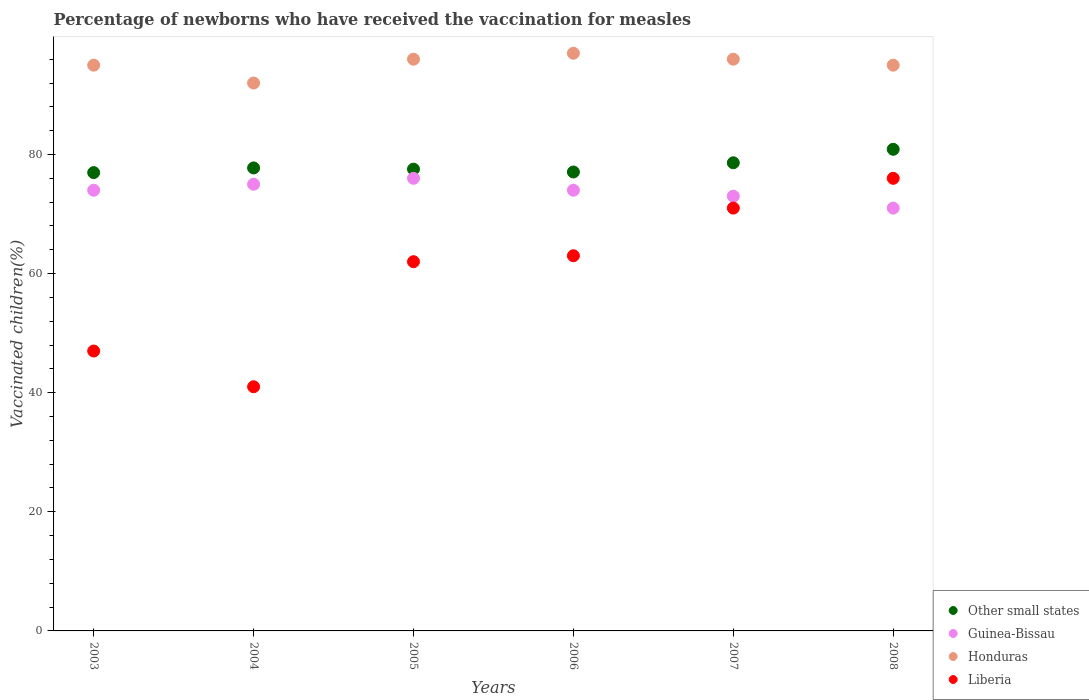How many different coloured dotlines are there?
Give a very brief answer. 4. Is the number of dotlines equal to the number of legend labels?
Provide a succinct answer. Yes. What is the percentage of vaccinated children in Other small states in 2007?
Your answer should be compact. 78.61. Across all years, what is the maximum percentage of vaccinated children in Honduras?
Offer a terse response. 97. Across all years, what is the minimum percentage of vaccinated children in Liberia?
Your response must be concise. 41. In which year was the percentage of vaccinated children in Honduras maximum?
Your answer should be very brief. 2006. What is the total percentage of vaccinated children in Liberia in the graph?
Give a very brief answer. 360. What is the difference between the percentage of vaccinated children in Other small states in 2003 and that in 2006?
Provide a short and direct response. -0.1. What is the difference between the percentage of vaccinated children in Guinea-Bissau in 2006 and the percentage of vaccinated children in Other small states in 2003?
Offer a terse response. -2.96. What is the average percentage of vaccinated children in Other small states per year?
Make the answer very short. 78.13. In the year 2007, what is the difference between the percentage of vaccinated children in Guinea-Bissau and percentage of vaccinated children in Honduras?
Ensure brevity in your answer.  -23. What is the ratio of the percentage of vaccinated children in Guinea-Bissau in 2003 to that in 2004?
Provide a short and direct response. 0.99. Is the percentage of vaccinated children in Liberia in 2003 less than that in 2008?
Your answer should be very brief. Yes. What is the difference between the highest and the second highest percentage of vaccinated children in Honduras?
Your answer should be compact. 1. What is the difference between the highest and the lowest percentage of vaccinated children in Liberia?
Your answer should be compact. 35. Is it the case that in every year, the sum of the percentage of vaccinated children in Other small states and percentage of vaccinated children in Liberia  is greater than the sum of percentage of vaccinated children in Guinea-Bissau and percentage of vaccinated children in Honduras?
Offer a very short reply. No. How many dotlines are there?
Provide a succinct answer. 4. How many legend labels are there?
Keep it short and to the point. 4. What is the title of the graph?
Offer a terse response. Percentage of newborns who have received the vaccination for measles. Does "Hungary" appear as one of the legend labels in the graph?
Provide a short and direct response. No. What is the label or title of the Y-axis?
Make the answer very short. Vaccinated children(%). What is the Vaccinated children(%) of Other small states in 2003?
Give a very brief answer. 76.96. What is the Vaccinated children(%) of Guinea-Bissau in 2003?
Ensure brevity in your answer.  74. What is the Vaccinated children(%) in Honduras in 2003?
Offer a very short reply. 95. What is the Vaccinated children(%) of Other small states in 2004?
Your answer should be very brief. 77.74. What is the Vaccinated children(%) of Honduras in 2004?
Give a very brief answer. 92. What is the Vaccinated children(%) in Other small states in 2005?
Your answer should be compact. 77.54. What is the Vaccinated children(%) in Honduras in 2005?
Offer a very short reply. 96. What is the Vaccinated children(%) of Liberia in 2005?
Give a very brief answer. 62. What is the Vaccinated children(%) in Other small states in 2006?
Your response must be concise. 77.06. What is the Vaccinated children(%) of Guinea-Bissau in 2006?
Provide a succinct answer. 74. What is the Vaccinated children(%) in Honduras in 2006?
Offer a terse response. 97. What is the Vaccinated children(%) of Other small states in 2007?
Offer a very short reply. 78.61. What is the Vaccinated children(%) of Guinea-Bissau in 2007?
Your response must be concise. 73. What is the Vaccinated children(%) in Honduras in 2007?
Make the answer very short. 96. What is the Vaccinated children(%) of Other small states in 2008?
Your response must be concise. 80.87. What is the Vaccinated children(%) in Guinea-Bissau in 2008?
Ensure brevity in your answer.  71. Across all years, what is the maximum Vaccinated children(%) of Other small states?
Your answer should be very brief. 80.87. Across all years, what is the maximum Vaccinated children(%) in Guinea-Bissau?
Give a very brief answer. 76. Across all years, what is the maximum Vaccinated children(%) in Honduras?
Ensure brevity in your answer.  97. Across all years, what is the maximum Vaccinated children(%) of Liberia?
Offer a very short reply. 76. Across all years, what is the minimum Vaccinated children(%) in Other small states?
Ensure brevity in your answer.  76.96. Across all years, what is the minimum Vaccinated children(%) of Guinea-Bissau?
Keep it short and to the point. 71. Across all years, what is the minimum Vaccinated children(%) of Honduras?
Offer a very short reply. 92. Across all years, what is the minimum Vaccinated children(%) in Liberia?
Keep it short and to the point. 41. What is the total Vaccinated children(%) of Other small states in the graph?
Give a very brief answer. 468.78. What is the total Vaccinated children(%) in Guinea-Bissau in the graph?
Provide a short and direct response. 443. What is the total Vaccinated children(%) of Honduras in the graph?
Provide a short and direct response. 571. What is the total Vaccinated children(%) in Liberia in the graph?
Your answer should be compact. 360. What is the difference between the Vaccinated children(%) of Other small states in 2003 and that in 2004?
Ensure brevity in your answer.  -0.78. What is the difference between the Vaccinated children(%) in Guinea-Bissau in 2003 and that in 2004?
Offer a terse response. -1. What is the difference between the Vaccinated children(%) of Honduras in 2003 and that in 2004?
Ensure brevity in your answer.  3. What is the difference between the Vaccinated children(%) in Other small states in 2003 and that in 2005?
Give a very brief answer. -0.58. What is the difference between the Vaccinated children(%) of Liberia in 2003 and that in 2005?
Your answer should be compact. -15. What is the difference between the Vaccinated children(%) in Other small states in 2003 and that in 2006?
Ensure brevity in your answer.  -0.1. What is the difference between the Vaccinated children(%) of Guinea-Bissau in 2003 and that in 2006?
Your answer should be very brief. 0. What is the difference between the Vaccinated children(%) in Liberia in 2003 and that in 2006?
Your answer should be compact. -16. What is the difference between the Vaccinated children(%) of Other small states in 2003 and that in 2007?
Give a very brief answer. -1.65. What is the difference between the Vaccinated children(%) of Honduras in 2003 and that in 2007?
Provide a short and direct response. -1. What is the difference between the Vaccinated children(%) of Liberia in 2003 and that in 2007?
Offer a very short reply. -24. What is the difference between the Vaccinated children(%) in Other small states in 2003 and that in 2008?
Offer a very short reply. -3.91. What is the difference between the Vaccinated children(%) of Guinea-Bissau in 2003 and that in 2008?
Offer a terse response. 3. What is the difference between the Vaccinated children(%) in Liberia in 2003 and that in 2008?
Ensure brevity in your answer.  -29. What is the difference between the Vaccinated children(%) of Other small states in 2004 and that in 2005?
Give a very brief answer. 0.2. What is the difference between the Vaccinated children(%) in Other small states in 2004 and that in 2006?
Provide a short and direct response. 0.68. What is the difference between the Vaccinated children(%) of Guinea-Bissau in 2004 and that in 2006?
Your answer should be compact. 1. What is the difference between the Vaccinated children(%) of Liberia in 2004 and that in 2006?
Offer a very short reply. -22. What is the difference between the Vaccinated children(%) of Other small states in 2004 and that in 2007?
Ensure brevity in your answer.  -0.86. What is the difference between the Vaccinated children(%) in Guinea-Bissau in 2004 and that in 2007?
Provide a succinct answer. 2. What is the difference between the Vaccinated children(%) in Honduras in 2004 and that in 2007?
Keep it short and to the point. -4. What is the difference between the Vaccinated children(%) of Other small states in 2004 and that in 2008?
Your answer should be compact. -3.13. What is the difference between the Vaccinated children(%) of Guinea-Bissau in 2004 and that in 2008?
Provide a succinct answer. 4. What is the difference between the Vaccinated children(%) in Honduras in 2004 and that in 2008?
Ensure brevity in your answer.  -3. What is the difference between the Vaccinated children(%) in Liberia in 2004 and that in 2008?
Offer a terse response. -35. What is the difference between the Vaccinated children(%) of Other small states in 2005 and that in 2006?
Offer a very short reply. 0.48. What is the difference between the Vaccinated children(%) of Honduras in 2005 and that in 2006?
Give a very brief answer. -1. What is the difference between the Vaccinated children(%) of Other small states in 2005 and that in 2007?
Give a very brief answer. -1.07. What is the difference between the Vaccinated children(%) in Guinea-Bissau in 2005 and that in 2007?
Make the answer very short. 3. What is the difference between the Vaccinated children(%) in Honduras in 2005 and that in 2007?
Keep it short and to the point. 0. What is the difference between the Vaccinated children(%) of Other small states in 2005 and that in 2008?
Provide a succinct answer. -3.33. What is the difference between the Vaccinated children(%) in Honduras in 2005 and that in 2008?
Provide a short and direct response. 1. What is the difference between the Vaccinated children(%) in Liberia in 2005 and that in 2008?
Provide a succinct answer. -14. What is the difference between the Vaccinated children(%) in Other small states in 2006 and that in 2007?
Offer a terse response. -1.55. What is the difference between the Vaccinated children(%) in Other small states in 2006 and that in 2008?
Provide a succinct answer. -3.81. What is the difference between the Vaccinated children(%) of Guinea-Bissau in 2006 and that in 2008?
Offer a very short reply. 3. What is the difference between the Vaccinated children(%) of Honduras in 2006 and that in 2008?
Your answer should be very brief. 2. What is the difference between the Vaccinated children(%) of Other small states in 2007 and that in 2008?
Your answer should be compact. -2.26. What is the difference between the Vaccinated children(%) of Other small states in 2003 and the Vaccinated children(%) of Guinea-Bissau in 2004?
Your answer should be compact. 1.96. What is the difference between the Vaccinated children(%) of Other small states in 2003 and the Vaccinated children(%) of Honduras in 2004?
Keep it short and to the point. -15.04. What is the difference between the Vaccinated children(%) in Other small states in 2003 and the Vaccinated children(%) in Liberia in 2004?
Your answer should be very brief. 35.96. What is the difference between the Vaccinated children(%) in Other small states in 2003 and the Vaccinated children(%) in Guinea-Bissau in 2005?
Keep it short and to the point. 0.96. What is the difference between the Vaccinated children(%) in Other small states in 2003 and the Vaccinated children(%) in Honduras in 2005?
Keep it short and to the point. -19.04. What is the difference between the Vaccinated children(%) in Other small states in 2003 and the Vaccinated children(%) in Liberia in 2005?
Your answer should be compact. 14.96. What is the difference between the Vaccinated children(%) in Guinea-Bissau in 2003 and the Vaccinated children(%) in Liberia in 2005?
Provide a short and direct response. 12. What is the difference between the Vaccinated children(%) in Honduras in 2003 and the Vaccinated children(%) in Liberia in 2005?
Provide a succinct answer. 33. What is the difference between the Vaccinated children(%) of Other small states in 2003 and the Vaccinated children(%) of Guinea-Bissau in 2006?
Make the answer very short. 2.96. What is the difference between the Vaccinated children(%) in Other small states in 2003 and the Vaccinated children(%) in Honduras in 2006?
Offer a terse response. -20.04. What is the difference between the Vaccinated children(%) of Other small states in 2003 and the Vaccinated children(%) of Liberia in 2006?
Give a very brief answer. 13.96. What is the difference between the Vaccinated children(%) of Guinea-Bissau in 2003 and the Vaccinated children(%) of Honduras in 2006?
Offer a terse response. -23. What is the difference between the Vaccinated children(%) in Other small states in 2003 and the Vaccinated children(%) in Guinea-Bissau in 2007?
Offer a terse response. 3.96. What is the difference between the Vaccinated children(%) of Other small states in 2003 and the Vaccinated children(%) of Honduras in 2007?
Your response must be concise. -19.04. What is the difference between the Vaccinated children(%) in Other small states in 2003 and the Vaccinated children(%) in Liberia in 2007?
Make the answer very short. 5.96. What is the difference between the Vaccinated children(%) of Guinea-Bissau in 2003 and the Vaccinated children(%) of Liberia in 2007?
Ensure brevity in your answer.  3. What is the difference between the Vaccinated children(%) in Honduras in 2003 and the Vaccinated children(%) in Liberia in 2007?
Offer a terse response. 24. What is the difference between the Vaccinated children(%) of Other small states in 2003 and the Vaccinated children(%) of Guinea-Bissau in 2008?
Provide a succinct answer. 5.96. What is the difference between the Vaccinated children(%) in Other small states in 2003 and the Vaccinated children(%) in Honduras in 2008?
Give a very brief answer. -18.04. What is the difference between the Vaccinated children(%) of Other small states in 2003 and the Vaccinated children(%) of Liberia in 2008?
Your answer should be compact. 0.96. What is the difference between the Vaccinated children(%) of Honduras in 2003 and the Vaccinated children(%) of Liberia in 2008?
Keep it short and to the point. 19. What is the difference between the Vaccinated children(%) in Other small states in 2004 and the Vaccinated children(%) in Guinea-Bissau in 2005?
Your answer should be very brief. 1.74. What is the difference between the Vaccinated children(%) in Other small states in 2004 and the Vaccinated children(%) in Honduras in 2005?
Provide a succinct answer. -18.26. What is the difference between the Vaccinated children(%) of Other small states in 2004 and the Vaccinated children(%) of Liberia in 2005?
Give a very brief answer. 15.74. What is the difference between the Vaccinated children(%) in Guinea-Bissau in 2004 and the Vaccinated children(%) in Liberia in 2005?
Provide a succinct answer. 13. What is the difference between the Vaccinated children(%) in Other small states in 2004 and the Vaccinated children(%) in Guinea-Bissau in 2006?
Provide a succinct answer. 3.74. What is the difference between the Vaccinated children(%) in Other small states in 2004 and the Vaccinated children(%) in Honduras in 2006?
Ensure brevity in your answer.  -19.26. What is the difference between the Vaccinated children(%) of Other small states in 2004 and the Vaccinated children(%) of Liberia in 2006?
Ensure brevity in your answer.  14.74. What is the difference between the Vaccinated children(%) of Guinea-Bissau in 2004 and the Vaccinated children(%) of Liberia in 2006?
Offer a terse response. 12. What is the difference between the Vaccinated children(%) of Honduras in 2004 and the Vaccinated children(%) of Liberia in 2006?
Offer a very short reply. 29. What is the difference between the Vaccinated children(%) in Other small states in 2004 and the Vaccinated children(%) in Guinea-Bissau in 2007?
Offer a very short reply. 4.74. What is the difference between the Vaccinated children(%) of Other small states in 2004 and the Vaccinated children(%) of Honduras in 2007?
Keep it short and to the point. -18.26. What is the difference between the Vaccinated children(%) in Other small states in 2004 and the Vaccinated children(%) in Liberia in 2007?
Keep it short and to the point. 6.74. What is the difference between the Vaccinated children(%) of Honduras in 2004 and the Vaccinated children(%) of Liberia in 2007?
Offer a terse response. 21. What is the difference between the Vaccinated children(%) in Other small states in 2004 and the Vaccinated children(%) in Guinea-Bissau in 2008?
Provide a short and direct response. 6.74. What is the difference between the Vaccinated children(%) in Other small states in 2004 and the Vaccinated children(%) in Honduras in 2008?
Your response must be concise. -17.26. What is the difference between the Vaccinated children(%) in Other small states in 2004 and the Vaccinated children(%) in Liberia in 2008?
Keep it short and to the point. 1.74. What is the difference between the Vaccinated children(%) in Guinea-Bissau in 2004 and the Vaccinated children(%) in Honduras in 2008?
Keep it short and to the point. -20. What is the difference between the Vaccinated children(%) in Guinea-Bissau in 2004 and the Vaccinated children(%) in Liberia in 2008?
Provide a short and direct response. -1. What is the difference between the Vaccinated children(%) in Honduras in 2004 and the Vaccinated children(%) in Liberia in 2008?
Provide a succinct answer. 16. What is the difference between the Vaccinated children(%) of Other small states in 2005 and the Vaccinated children(%) of Guinea-Bissau in 2006?
Your answer should be compact. 3.54. What is the difference between the Vaccinated children(%) of Other small states in 2005 and the Vaccinated children(%) of Honduras in 2006?
Ensure brevity in your answer.  -19.46. What is the difference between the Vaccinated children(%) of Other small states in 2005 and the Vaccinated children(%) of Liberia in 2006?
Ensure brevity in your answer.  14.54. What is the difference between the Vaccinated children(%) of Guinea-Bissau in 2005 and the Vaccinated children(%) of Honduras in 2006?
Ensure brevity in your answer.  -21. What is the difference between the Vaccinated children(%) of Honduras in 2005 and the Vaccinated children(%) of Liberia in 2006?
Offer a very short reply. 33. What is the difference between the Vaccinated children(%) of Other small states in 2005 and the Vaccinated children(%) of Guinea-Bissau in 2007?
Provide a succinct answer. 4.54. What is the difference between the Vaccinated children(%) in Other small states in 2005 and the Vaccinated children(%) in Honduras in 2007?
Your response must be concise. -18.46. What is the difference between the Vaccinated children(%) in Other small states in 2005 and the Vaccinated children(%) in Liberia in 2007?
Your answer should be very brief. 6.54. What is the difference between the Vaccinated children(%) of Guinea-Bissau in 2005 and the Vaccinated children(%) of Honduras in 2007?
Offer a very short reply. -20. What is the difference between the Vaccinated children(%) in Honduras in 2005 and the Vaccinated children(%) in Liberia in 2007?
Provide a short and direct response. 25. What is the difference between the Vaccinated children(%) in Other small states in 2005 and the Vaccinated children(%) in Guinea-Bissau in 2008?
Provide a succinct answer. 6.54. What is the difference between the Vaccinated children(%) in Other small states in 2005 and the Vaccinated children(%) in Honduras in 2008?
Make the answer very short. -17.46. What is the difference between the Vaccinated children(%) in Other small states in 2005 and the Vaccinated children(%) in Liberia in 2008?
Your answer should be compact. 1.54. What is the difference between the Vaccinated children(%) in Guinea-Bissau in 2005 and the Vaccinated children(%) in Honduras in 2008?
Ensure brevity in your answer.  -19. What is the difference between the Vaccinated children(%) in Other small states in 2006 and the Vaccinated children(%) in Guinea-Bissau in 2007?
Keep it short and to the point. 4.06. What is the difference between the Vaccinated children(%) in Other small states in 2006 and the Vaccinated children(%) in Honduras in 2007?
Your answer should be compact. -18.94. What is the difference between the Vaccinated children(%) of Other small states in 2006 and the Vaccinated children(%) of Liberia in 2007?
Make the answer very short. 6.06. What is the difference between the Vaccinated children(%) in Guinea-Bissau in 2006 and the Vaccinated children(%) in Honduras in 2007?
Provide a succinct answer. -22. What is the difference between the Vaccinated children(%) of Other small states in 2006 and the Vaccinated children(%) of Guinea-Bissau in 2008?
Provide a short and direct response. 6.06. What is the difference between the Vaccinated children(%) of Other small states in 2006 and the Vaccinated children(%) of Honduras in 2008?
Give a very brief answer. -17.94. What is the difference between the Vaccinated children(%) of Other small states in 2006 and the Vaccinated children(%) of Liberia in 2008?
Give a very brief answer. 1.06. What is the difference between the Vaccinated children(%) in Guinea-Bissau in 2006 and the Vaccinated children(%) in Liberia in 2008?
Provide a succinct answer. -2. What is the difference between the Vaccinated children(%) in Other small states in 2007 and the Vaccinated children(%) in Guinea-Bissau in 2008?
Ensure brevity in your answer.  7.61. What is the difference between the Vaccinated children(%) in Other small states in 2007 and the Vaccinated children(%) in Honduras in 2008?
Ensure brevity in your answer.  -16.39. What is the difference between the Vaccinated children(%) in Other small states in 2007 and the Vaccinated children(%) in Liberia in 2008?
Provide a succinct answer. 2.61. What is the difference between the Vaccinated children(%) in Honduras in 2007 and the Vaccinated children(%) in Liberia in 2008?
Your response must be concise. 20. What is the average Vaccinated children(%) of Other small states per year?
Keep it short and to the point. 78.13. What is the average Vaccinated children(%) of Guinea-Bissau per year?
Offer a terse response. 73.83. What is the average Vaccinated children(%) in Honduras per year?
Give a very brief answer. 95.17. What is the average Vaccinated children(%) in Liberia per year?
Ensure brevity in your answer.  60. In the year 2003, what is the difference between the Vaccinated children(%) in Other small states and Vaccinated children(%) in Guinea-Bissau?
Your answer should be very brief. 2.96. In the year 2003, what is the difference between the Vaccinated children(%) of Other small states and Vaccinated children(%) of Honduras?
Make the answer very short. -18.04. In the year 2003, what is the difference between the Vaccinated children(%) of Other small states and Vaccinated children(%) of Liberia?
Make the answer very short. 29.96. In the year 2004, what is the difference between the Vaccinated children(%) of Other small states and Vaccinated children(%) of Guinea-Bissau?
Your response must be concise. 2.74. In the year 2004, what is the difference between the Vaccinated children(%) of Other small states and Vaccinated children(%) of Honduras?
Ensure brevity in your answer.  -14.26. In the year 2004, what is the difference between the Vaccinated children(%) of Other small states and Vaccinated children(%) of Liberia?
Provide a short and direct response. 36.74. In the year 2004, what is the difference between the Vaccinated children(%) of Guinea-Bissau and Vaccinated children(%) of Honduras?
Your response must be concise. -17. In the year 2004, what is the difference between the Vaccinated children(%) of Guinea-Bissau and Vaccinated children(%) of Liberia?
Keep it short and to the point. 34. In the year 2005, what is the difference between the Vaccinated children(%) in Other small states and Vaccinated children(%) in Guinea-Bissau?
Keep it short and to the point. 1.54. In the year 2005, what is the difference between the Vaccinated children(%) in Other small states and Vaccinated children(%) in Honduras?
Keep it short and to the point. -18.46. In the year 2005, what is the difference between the Vaccinated children(%) in Other small states and Vaccinated children(%) in Liberia?
Your answer should be compact. 15.54. In the year 2005, what is the difference between the Vaccinated children(%) of Guinea-Bissau and Vaccinated children(%) of Liberia?
Give a very brief answer. 14. In the year 2006, what is the difference between the Vaccinated children(%) of Other small states and Vaccinated children(%) of Guinea-Bissau?
Offer a terse response. 3.06. In the year 2006, what is the difference between the Vaccinated children(%) in Other small states and Vaccinated children(%) in Honduras?
Ensure brevity in your answer.  -19.94. In the year 2006, what is the difference between the Vaccinated children(%) of Other small states and Vaccinated children(%) of Liberia?
Provide a succinct answer. 14.06. In the year 2006, what is the difference between the Vaccinated children(%) in Guinea-Bissau and Vaccinated children(%) in Honduras?
Give a very brief answer. -23. In the year 2007, what is the difference between the Vaccinated children(%) of Other small states and Vaccinated children(%) of Guinea-Bissau?
Keep it short and to the point. 5.61. In the year 2007, what is the difference between the Vaccinated children(%) in Other small states and Vaccinated children(%) in Honduras?
Your answer should be very brief. -17.39. In the year 2007, what is the difference between the Vaccinated children(%) in Other small states and Vaccinated children(%) in Liberia?
Ensure brevity in your answer.  7.61. In the year 2007, what is the difference between the Vaccinated children(%) in Honduras and Vaccinated children(%) in Liberia?
Give a very brief answer. 25. In the year 2008, what is the difference between the Vaccinated children(%) of Other small states and Vaccinated children(%) of Guinea-Bissau?
Your response must be concise. 9.87. In the year 2008, what is the difference between the Vaccinated children(%) in Other small states and Vaccinated children(%) in Honduras?
Provide a short and direct response. -14.13. In the year 2008, what is the difference between the Vaccinated children(%) in Other small states and Vaccinated children(%) in Liberia?
Offer a terse response. 4.87. In the year 2008, what is the difference between the Vaccinated children(%) in Honduras and Vaccinated children(%) in Liberia?
Provide a short and direct response. 19. What is the ratio of the Vaccinated children(%) in Other small states in 2003 to that in 2004?
Ensure brevity in your answer.  0.99. What is the ratio of the Vaccinated children(%) in Guinea-Bissau in 2003 to that in 2004?
Your answer should be compact. 0.99. What is the ratio of the Vaccinated children(%) in Honduras in 2003 to that in 2004?
Your answer should be very brief. 1.03. What is the ratio of the Vaccinated children(%) in Liberia in 2003 to that in 2004?
Provide a short and direct response. 1.15. What is the ratio of the Vaccinated children(%) in Guinea-Bissau in 2003 to that in 2005?
Provide a succinct answer. 0.97. What is the ratio of the Vaccinated children(%) in Honduras in 2003 to that in 2005?
Your response must be concise. 0.99. What is the ratio of the Vaccinated children(%) of Liberia in 2003 to that in 2005?
Ensure brevity in your answer.  0.76. What is the ratio of the Vaccinated children(%) in Guinea-Bissau in 2003 to that in 2006?
Keep it short and to the point. 1. What is the ratio of the Vaccinated children(%) in Honduras in 2003 to that in 2006?
Make the answer very short. 0.98. What is the ratio of the Vaccinated children(%) in Liberia in 2003 to that in 2006?
Provide a short and direct response. 0.75. What is the ratio of the Vaccinated children(%) of Other small states in 2003 to that in 2007?
Offer a terse response. 0.98. What is the ratio of the Vaccinated children(%) in Guinea-Bissau in 2003 to that in 2007?
Your answer should be compact. 1.01. What is the ratio of the Vaccinated children(%) in Honduras in 2003 to that in 2007?
Provide a succinct answer. 0.99. What is the ratio of the Vaccinated children(%) of Liberia in 2003 to that in 2007?
Your answer should be very brief. 0.66. What is the ratio of the Vaccinated children(%) in Other small states in 2003 to that in 2008?
Your response must be concise. 0.95. What is the ratio of the Vaccinated children(%) of Guinea-Bissau in 2003 to that in 2008?
Your answer should be very brief. 1.04. What is the ratio of the Vaccinated children(%) of Honduras in 2003 to that in 2008?
Provide a succinct answer. 1. What is the ratio of the Vaccinated children(%) of Liberia in 2003 to that in 2008?
Make the answer very short. 0.62. What is the ratio of the Vaccinated children(%) of Honduras in 2004 to that in 2005?
Your response must be concise. 0.96. What is the ratio of the Vaccinated children(%) of Liberia in 2004 to that in 2005?
Your answer should be very brief. 0.66. What is the ratio of the Vaccinated children(%) in Other small states in 2004 to that in 2006?
Keep it short and to the point. 1.01. What is the ratio of the Vaccinated children(%) of Guinea-Bissau in 2004 to that in 2006?
Offer a very short reply. 1.01. What is the ratio of the Vaccinated children(%) of Honduras in 2004 to that in 2006?
Your answer should be compact. 0.95. What is the ratio of the Vaccinated children(%) in Liberia in 2004 to that in 2006?
Offer a very short reply. 0.65. What is the ratio of the Vaccinated children(%) in Guinea-Bissau in 2004 to that in 2007?
Your response must be concise. 1.03. What is the ratio of the Vaccinated children(%) of Honduras in 2004 to that in 2007?
Give a very brief answer. 0.96. What is the ratio of the Vaccinated children(%) in Liberia in 2004 to that in 2007?
Make the answer very short. 0.58. What is the ratio of the Vaccinated children(%) in Other small states in 2004 to that in 2008?
Your answer should be very brief. 0.96. What is the ratio of the Vaccinated children(%) in Guinea-Bissau in 2004 to that in 2008?
Offer a very short reply. 1.06. What is the ratio of the Vaccinated children(%) of Honduras in 2004 to that in 2008?
Provide a short and direct response. 0.97. What is the ratio of the Vaccinated children(%) in Liberia in 2004 to that in 2008?
Your answer should be very brief. 0.54. What is the ratio of the Vaccinated children(%) in Guinea-Bissau in 2005 to that in 2006?
Provide a succinct answer. 1.03. What is the ratio of the Vaccinated children(%) in Liberia in 2005 to that in 2006?
Your response must be concise. 0.98. What is the ratio of the Vaccinated children(%) in Other small states in 2005 to that in 2007?
Keep it short and to the point. 0.99. What is the ratio of the Vaccinated children(%) in Guinea-Bissau in 2005 to that in 2007?
Keep it short and to the point. 1.04. What is the ratio of the Vaccinated children(%) in Honduras in 2005 to that in 2007?
Keep it short and to the point. 1. What is the ratio of the Vaccinated children(%) in Liberia in 2005 to that in 2007?
Your answer should be very brief. 0.87. What is the ratio of the Vaccinated children(%) in Other small states in 2005 to that in 2008?
Give a very brief answer. 0.96. What is the ratio of the Vaccinated children(%) of Guinea-Bissau in 2005 to that in 2008?
Make the answer very short. 1.07. What is the ratio of the Vaccinated children(%) of Honduras in 2005 to that in 2008?
Your answer should be very brief. 1.01. What is the ratio of the Vaccinated children(%) of Liberia in 2005 to that in 2008?
Make the answer very short. 0.82. What is the ratio of the Vaccinated children(%) of Other small states in 2006 to that in 2007?
Your answer should be very brief. 0.98. What is the ratio of the Vaccinated children(%) of Guinea-Bissau in 2006 to that in 2007?
Give a very brief answer. 1.01. What is the ratio of the Vaccinated children(%) in Honduras in 2006 to that in 2007?
Keep it short and to the point. 1.01. What is the ratio of the Vaccinated children(%) in Liberia in 2006 to that in 2007?
Provide a succinct answer. 0.89. What is the ratio of the Vaccinated children(%) in Other small states in 2006 to that in 2008?
Your response must be concise. 0.95. What is the ratio of the Vaccinated children(%) of Guinea-Bissau in 2006 to that in 2008?
Ensure brevity in your answer.  1.04. What is the ratio of the Vaccinated children(%) in Honduras in 2006 to that in 2008?
Your answer should be very brief. 1.02. What is the ratio of the Vaccinated children(%) in Liberia in 2006 to that in 2008?
Keep it short and to the point. 0.83. What is the ratio of the Vaccinated children(%) of Guinea-Bissau in 2007 to that in 2008?
Offer a very short reply. 1.03. What is the ratio of the Vaccinated children(%) in Honduras in 2007 to that in 2008?
Offer a terse response. 1.01. What is the ratio of the Vaccinated children(%) in Liberia in 2007 to that in 2008?
Your answer should be compact. 0.93. What is the difference between the highest and the second highest Vaccinated children(%) in Other small states?
Give a very brief answer. 2.26. What is the difference between the highest and the second highest Vaccinated children(%) in Guinea-Bissau?
Your response must be concise. 1. What is the difference between the highest and the lowest Vaccinated children(%) in Other small states?
Provide a succinct answer. 3.91. What is the difference between the highest and the lowest Vaccinated children(%) of Honduras?
Keep it short and to the point. 5. What is the difference between the highest and the lowest Vaccinated children(%) in Liberia?
Your answer should be compact. 35. 